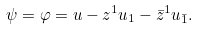Convert formula to latex. <formula><loc_0><loc_0><loc_500><loc_500>\psi = \varphi = u - z ^ { 1 } u _ { 1 } - \bar { z } ^ { 1 } u _ { \bar { 1 } } .</formula> 